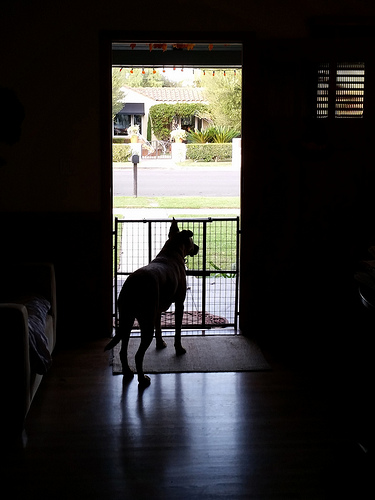<image>
Is there a grid in front of the dog? No. The grid is not in front of the dog. The spatial positioning shows a different relationship between these objects. Is there a dog to the left of the gate? No. The dog is not to the left of the gate. From this viewpoint, they have a different horizontal relationship. 